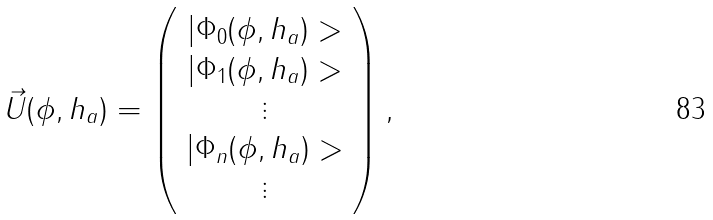<formula> <loc_0><loc_0><loc_500><loc_500>\vec { U } ( \phi , h _ { a } ) = \left ( \begin{array} { c } | \Phi _ { 0 } ( \phi , h _ { a } ) > \\ | \Phi _ { 1 } ( \phi , h _ { a } ) > \\ \vdots \\ | \Phi _ { n } ( \phi , h _ { a } ) > \\ \vdots \end{array} \right ) ,</formula> 